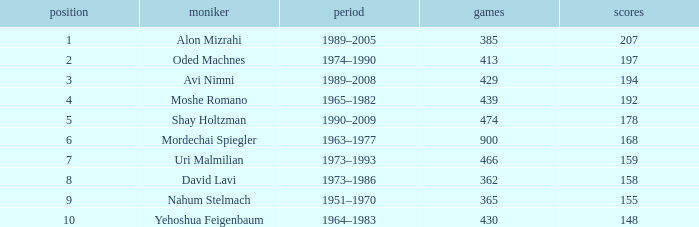What is the Rank of the player with 158 Goals in more than 362 Matches? 0.0. 